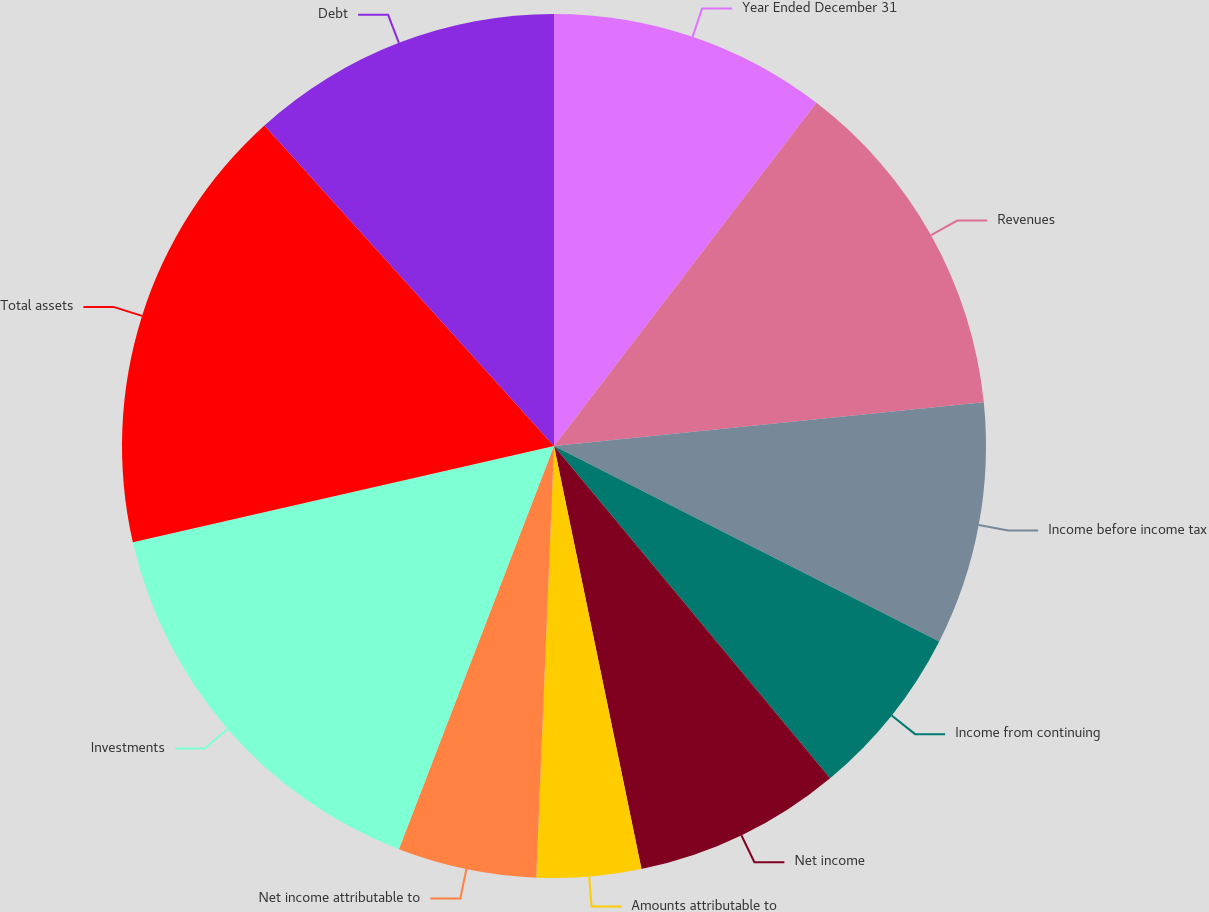<chart> <loc_0><loc_0><loc_500><loc_500><pie_chart><fcel>Year Ended December 31<fcel>Revenues<fcel>Income before income tax<fcel>Income from continuing<fcel>Net income<fcel>Amounts attributable to<fcel>Net income attributable to<fcel>Investments<fcel>Total assets<fcel>Debt<nl><fcel>10.39%<fcel>12.99%<fcel>9.09%<fcel>6.49%<fcel>7.79%<fcel>3.9%<fcel>5.19%<fcel>15.58%<fcel>16.88%<fcel>11.69%<nl></chart> 